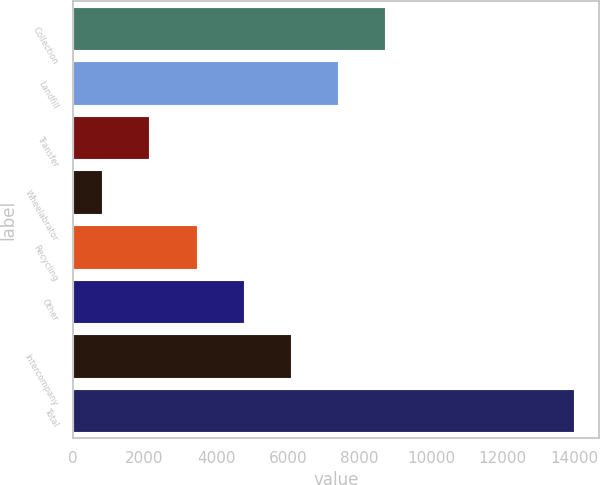Convert chart. <chart><loc_0><loc_0><loc_500><loc_500><bar_chart><fcel>Collection<fcel>Landfill<fcel>Transfer<fcel>Wheelabrator<fcel>Recycling<fcel>Other<fcel>Intercompany<fcel>Total<nl><fcel>8724.4<fcel>7406.5<fcel>2134.9<fcel>817<fcel>3452.8<fcel>4770.7<fcel>6088.6<fcel>13996<nl></chart> 